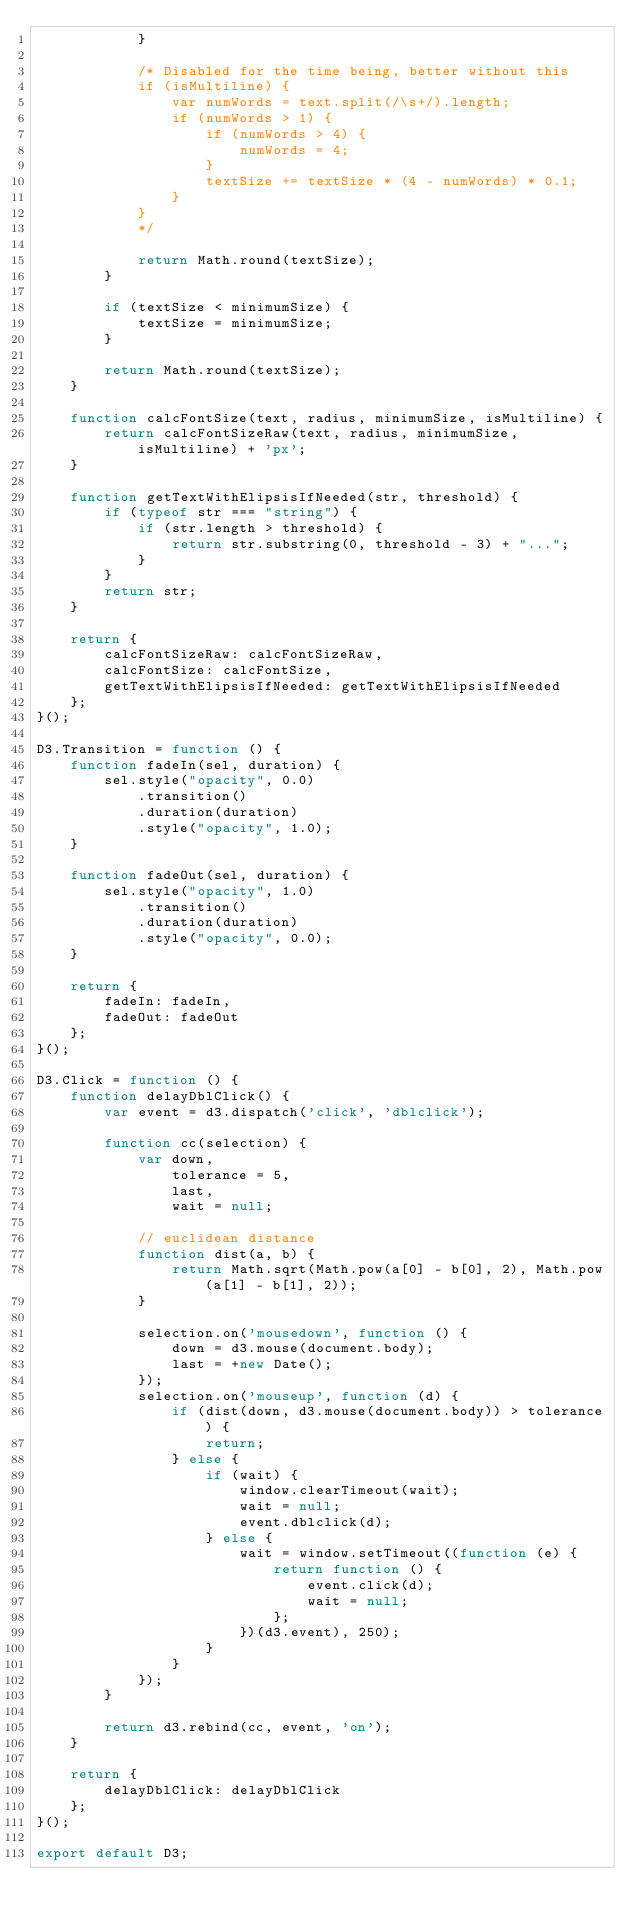<code> <loc_0><loc_0><loc_500><loc_500><_JavaScript_>            }

            /* Disabled for the time being, better without this
            if (isMultiline) {
                var numWords = text.split(/\s+/).length;
                if (numWords > 1) {
                    if (numWords > 4) {
                        numWords = 4;
                    }
                    textSize += textSize * (4 - numWords) * 0.1;
                }
            }
            */

            return Math.round(textSize);
        }

        if (textSize < minimumSize) {
            textSize = minimumSize;
        }

        return Math.round(textSize);
    }

    function calcFontSize(text, radius, minimumSize, isMultiline) {
        return calcFontSizeRaw(text, radius, minimumSize, isMultiline) + 'px';
    }

    function getTextWithElipsisIfNeeded(str, threshold) {
        if (typeof str === "string") {
            if (str.length > threshold) {
                return str.substring(0, threshold - 3) + "...";
            }
        }
        return str;
    }

    return {
        calcFontSizeRaw: calcFontSizeRaw,
        calcFontSize: calcFontSize,
        getTextWithElipsisIfNeeded: getTextWithElipsisIfNeeded
    };
}();

D3.Transition = function () {
    function fadeIn(sel, duration) {
        sel.style("opacity", 0.0)
            .transition()
            .duration(duration)
            .style("opacity", 1.0);
    }

    function fadeOut(sel, duration) {
        sel.style("opacity", 1.0)
            .transition()
            .duration(duration)
            .style("opacity", 0.0);
    }

    return {
        fadeIn: fadeIn,
        fadeOut: fadeOut
    };
}();

D3.Click = function () {
    function delayDblClick() {
        var event = d3.dispatch('click', 'dblclick');

        function cc(selection) {
            var down,
                tolerance = 5,
                last,
                wait = null;

            // euclidean distance
            function dist(a, b) {
                return Math.sqrt(Math.pow(a[0] - b[0], 2), Math.pow(a[1] - b[1], 2));
            }

            selection.on('mousedown', function () {
                down = d3.mouse(document.body);
                last = +new Date();
            });
            selection.on('mouseup', function (d) {
                if (dist(down, d3.mouse(document.body)) > tolerance) {
                    return;
                } else {
                    if (wait) {
                        window.clearTimeout(wait);
                        wait = null;
                        event.dblclick(d);
                    } else {
                        wait = window.setTimeout((function (e) {
                            return function () {
                                event.click(d);
                                wait = null;
                            };
                        })(d3.event), 250);
                    }
                }
            });
        }

        return d3.rebind(cc, event, 'on');
    }

    return {
        delayDblClick: delayDblClick
    };
}();

export default D3;
</code> 